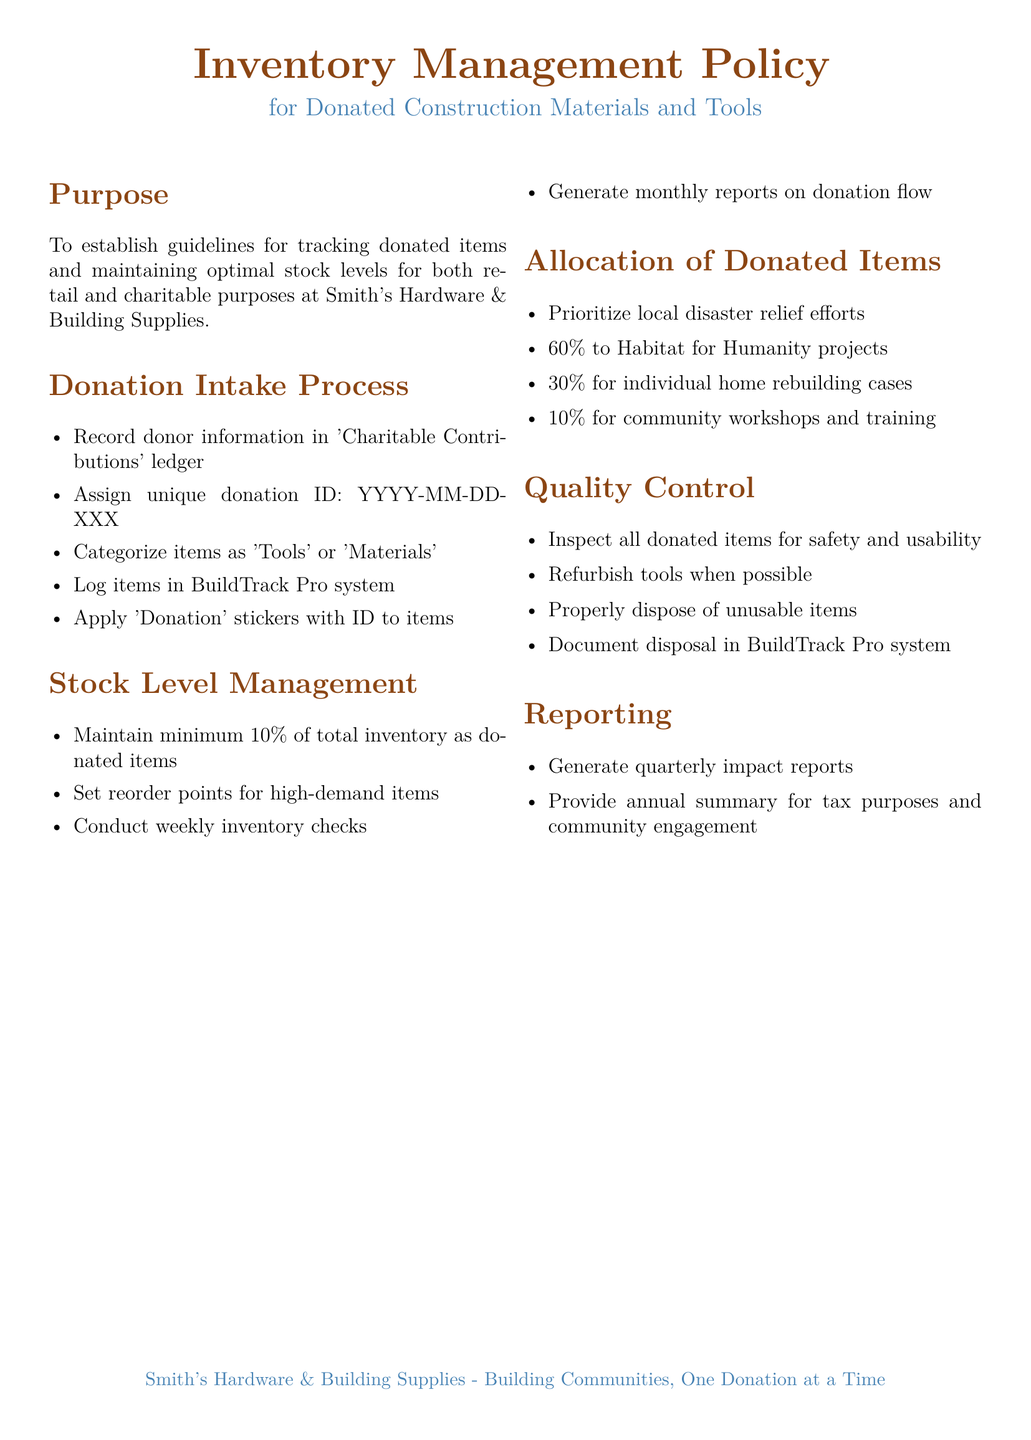What is the main purpose of the policy? The purpose section outlines that the guidelines are established for tracking donated items and maintaining stock levels.
Answer: To establish guidelines for tracking donated items and maintaining optimal stock levels What is the minimum percentage of inventory that should be donated items? The policy specifies that at least 10% of total inventory must be donated items.
Answer: 10% How often should inventory checks be conducted? The stock level management section states that inventory checks should occur on a weekly basis.
Answer: Weekly What is the percentage allocation for Habitat for Humanity projects? The allocation section indicates that 60% of donated items are prioritized for Habitat for Humanity.
Answer: 60% Which system should be used to log donated items? The donation intake process mentions that items should be logged in the BuildTrack Pro system.
Answer: BuildTrack Pro What should be done with unusable items? The quality control section requires that unusable items must be properly disposed of.
Answer: Properly dispose of unusable items When are quarterly impact reports generated? The reporting section specifies that impact reports are generated quarterly, but does not provide a specific date.
Answer: Quarterly What is the unique donation ID format? The donation intake process describes the format for the unique donation ID that includes a date and three digits.
Answer: YYYY-MM-DD-XXX 